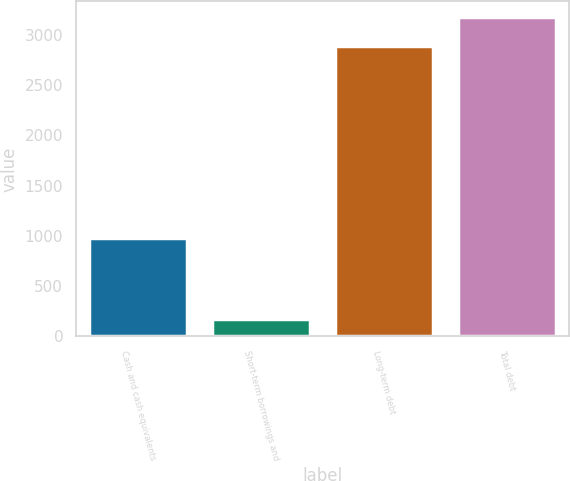<chart> <loc_0><loc_0><loc_500><loc_500><bar_chart><fcel>Cash and cash equivalents<fcel>Short-term borrowings and<fcel>Long-term debt<fcel>Total debt<nl><fcel>984<fcel>177<fcel>2887<fcel>3175.7<nl></chart> 